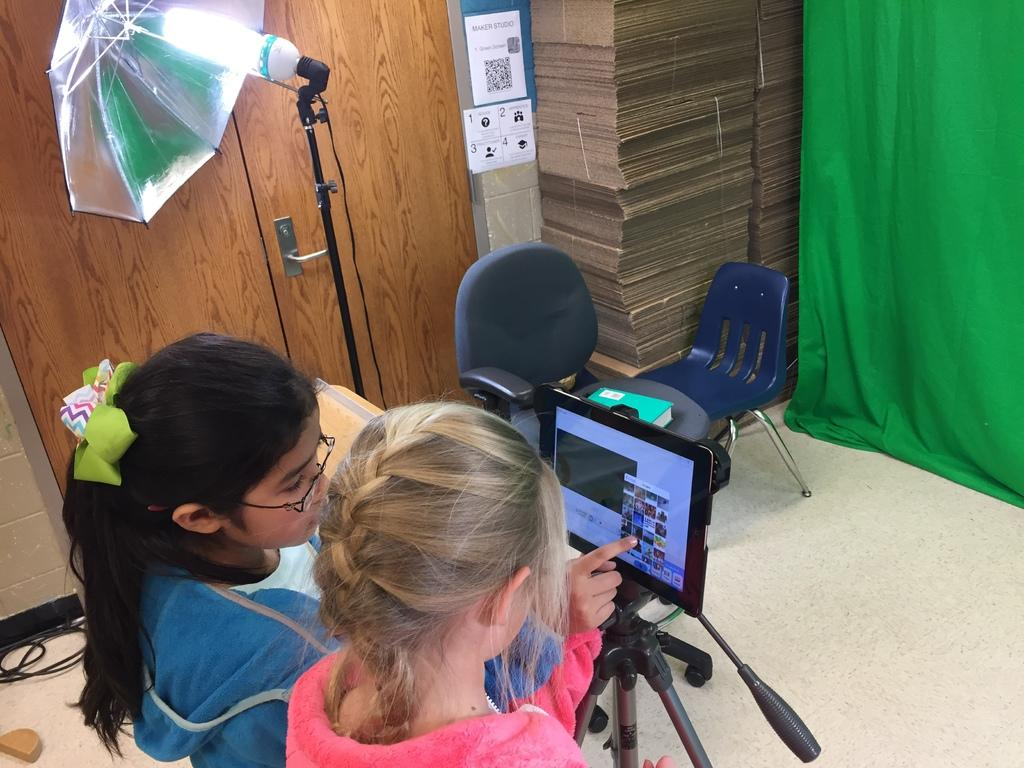How many girls are in the image? There are two girls in the image. What are the girls looking at? The girls are looking at a tab. How is the tab positioned in the image? The tab is on a tripod. What can be seen in the background of the image? There is a door, an umbrella, a light, chairs, a wall, and a curtain in the background of the image. What type of unit is being measured by the girls in the image? There is no indication in the image that the girls are measuring any units. What substance is being poured into the cup in the image? There is no cup present in the image. 